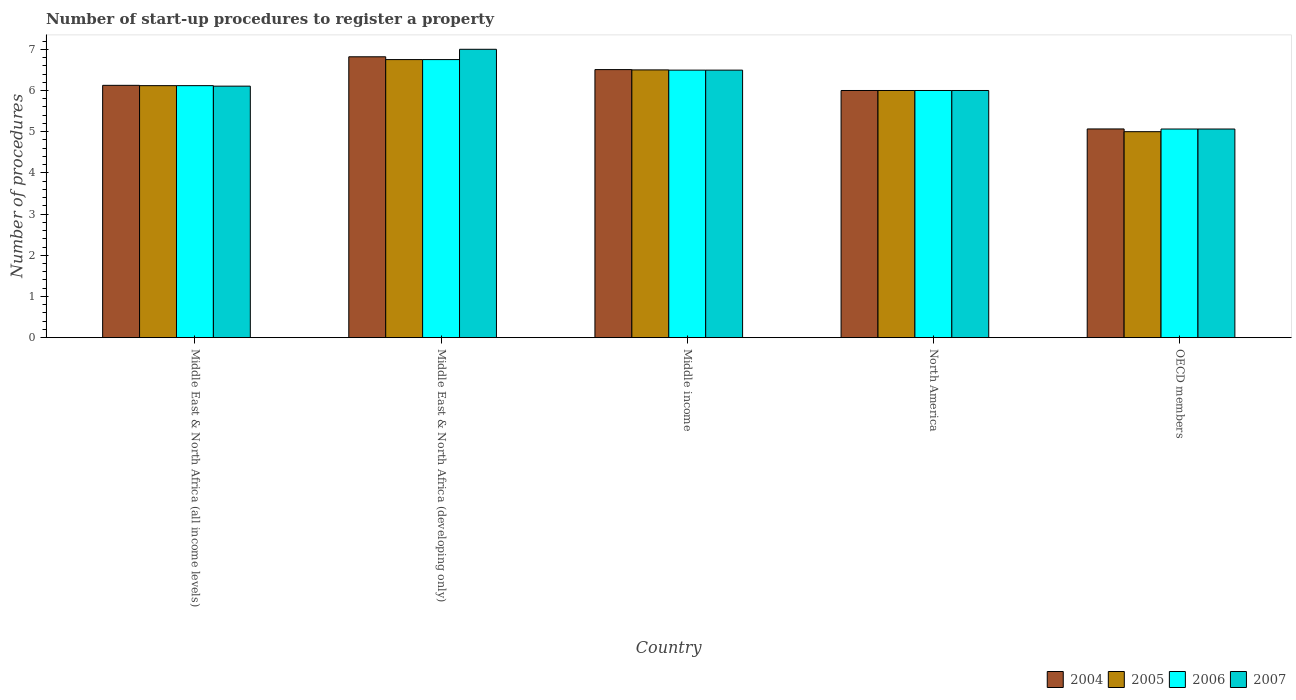Are the number of bars per tick equal to the number of legend labels?
Your answer should be very brief. Yes. How many bars are there on the 2nd tick from the left?
Offer a very short reply. 4. How many bars are there on the 5th tick from the right?
Offer a terse response. 4. What is the number of procedures required to register a property in 2004 in Middle East & North Africa (all income levels)?
Ensure brevity in your answer.  6.12. Across all countries, what is the maximum number of procedures required to register a property in 2005?
Offer a very short reply. 6.75. Across all countries, what is the minimum number of procedures required to register a property in 2005?
Your answer should be compact. 5. In which country was the number of procedures required to register a property in 2007 maximum?
Your response must be concise. Middle East & North Africa (developing only). In which country was the number of procedures required to register a property in 2006 minimum?
Provide a short and direct response. OECD members. What is the total number of procedures required to register a property in 2005 in the graph?
Make the answer very short. 30.37. What is the difference between the number of procedures required to register a property in 2005 in Middle East & North Africa (developing only) and that in Middle income?
Make the answer very short. 0.25. What is the difference between the number of procedures required to register a property in 2005 in Middle East & North Africa (developing only) and the number of procedures required to register a property in 2007 in Middle East & North Africa (all income levels)?
Provide a short and direct response. 0.64. What is the average number of procedures required to register a property in 2006 per country?
Give a very brief answer. 6.09. In how many countries, is the number of procedures required to register a property in 2006 greater than 0.4?
Your answer should be compact. 5. What is the ratio of the number of procedures required to register a property in 2006 in Middle income to that in North America?
Make the answer very short. 1.08. Is the number of procedures required to register a property in 2005 in Middle income less than that in North America?
Give a very brief answer. No. Is the difference between the number of procedures required to register a property in 2005 in Middle East & North Africa (all income levels) and OECD members greater than the difference between the number of procedures required to register a property in 2006 in Middle East & North Africa (all income levels) and OECD members?
Offer a very short reply. Yes. What is the difference between the highest and the second highest number of procedures required to register a property in 2004?
Keep it short and to the point. -0.69. What is the difference between the highest and the lowest number of procedures required to register a property in 2006?
Your response must be concise. 1.69. Is the sum of the number of procedures required to register a property in 2007 in Middle East & North Africa (developing only) and OECD members greater than the maximum number of procedures required to register a property in 2004 across all countries?
Offer a terse response. Yes. What does the 4th bar from the right in North America represents?
Make the answer very short. 2004. Is it the case that in every country, the sum of the number of procedures required to register a property in 2006 and number of procedures required to register a property in 2004 is greater than the number of procedures required to register a property in 2007?
Make the answer very short. Yes. Are all the bars in the graph horizontal?
Your response must be concise. No. What is the difference between two consecutive major ticks on the Y-axis?
Provide a succinct answer. 1. Does the graph contain any zero values?
Ensure brevity in your answer.  No. Where does the legend appear in the graph?
Ensure brevity in your answer.  Bottom right. How many legend labels are there?
Provide a short and direct response. 4. What is the title of the graph?
Make the answer very short. Number of start-up procedures to register a property. Does "1985" appear as one of the legend labels in the graph?
Provide a succinct answer. No. What is the label or title of the Y-axis?
Provide a short and direct response. Number of procedures. What is the Number of procedures in 2004 in Middle East & North Africa (all income levels)?
Provide a succinct answer. 6.12. What is the Number of procedures of 2005 in Middle East & North Africa (all income levels)?
Your answer should be very brief. 6.12. What is the Number of procedures of 2006 in Middle East & North Africa (all income levels)?
Give a very brief answer. 6.12. What is the Number of procedures of 2007 in Middle East & North Africa (all income levels)?
Offer a very short reply. 6.11. What is the Number of procedures in 2004 in Middle East & North Africa (developing only)?
Provide a succinct answer. 6.82. What is the Number of procedures of 2005 in Middle East & North Africa (developing only)?
Make the answer very short. 6.75. What is the Number of procedures of 2006 in Middle East & North Africa (developing only)?
Provide a succinct answer. 6.75. What is the Number of procedures in 2004 in Middle income?
Offer a very short reply. 6.51. What is the Number of procedures of 2005 in Middle income?
Provide a succinct answer. 6.5. What is the Number of procedures of 2006 in Middle income?
Make the answer very short. 6.49. What is the Number of procedures of 2007 in Middle income?
Your answer should be very brief. 6.49. What is the Number of procedures of 2005 in North America?
Make the answer very short. 6. What is the Number of procedures in 2004 in OECD members?
Your response must be concise. 5.07. What is the Number of procedures of 2006 in OECD members?
Provide a short and direct response. 5.06. What is the Number of procedures in 2007 in OECD members?
Give a very brief answer. 5.06. Across all countries, what is the maximum Number of procedures of 2004?
Your answer should be very brief. 6.82. Across all countries, what is the maximum Number of procedures in 2005?
Give a very brief answer. 6.75. Across all countries, what is the maximum Number of procedures in 2006?
Provide a short and direct response. 6.75. Across all countries, what is the minimum Number of procedures of 2004?
Your answer should be compact. 5.07. Across all countries, what is the minimum Number of procedures of 2006?
Ensure brevity in your answer.  5.06. Across all countries, what is the minimum Number of procedures in 2007?
Your answer should be compact. 5.06. What is the total Number of procedures of 2004 in the graph?
Offer a very short reply. 30.52. What is the total Number of procedures in 2005 in the graph?
Give a very brief answer. 30.37. What is the total Number of procedures in 2006 in the graph?
Provide a succinct answer. 30.43. What is the total Number of procedures in 2007 in the graph?
Keep it short and to the point. 30.66. What is the difference between the Number of procedures in 2004 in Middle East & North Africa (all income levels) and that in Middle East & North Africa (developing only)?
Keep it short and to the point. -0.69. What is the difference between the Number of procedures in 2005 in Middle East & North Africa (all income levels) and that in Middle East & North Africa (developing only)?
Ensure brevity in your answer.  -0.63. What is the difference between the Number of procedures in 2006 in Middle East & North Africa (all income levels) and that in Middle East & North Africa (developing only)?
Your answer should be compact. -0.63. What is the difference between the Number of procedures of 2007 in Middle East & North Africa (all income levels) and that in Middle East & North Africa (developing only)?
Offer a terse response. -0.89. What is the difference between the Number of procedures of 2004 in Middle East & North Africa (all income levels) and that in Middle income?
Your response must be concise. -0.38. What is the difference between the Number of procedures of 2005 in Middle East & North Africa (all income levels) and that in Middle income?
Provide a succinct answer. -0.38. What is the difference between the Number of procedures in 2006 in Middle East & North Africa (all income levels) and that in Middle income?
Give a very brief answer. -0.38. What is the difference between the Number of procedures in 2007 in Middle East & North Africa (all income levels) and that in Middle income?
Your answer should be very brief. -0.39. What is the difference between the Number of procedures of 2004 in Middle East & North Africa (all income levels) and that in North America?
Offer a terse response. 0.12. What is the difference between the Number of procedures in 2005 in Middle East & North Africa (all income levels) and that in North America?
Ensure brevity in your answer.  0.12. What is the difference between the Number of procedures of 2006 in Middle East & North Africa (all income levels) and that in North America?
Provide a succinct answer. 0.12. What is the difference between the Number of procedures in 2007 in Middle East & North Africa (all income levels) and that in North America?
Provide a succinct answer. 0.11. What is the difference between the Number of procedures in 2004 in Middle East & North Africa (all income levels) and that in OECD members?
Provide a short and direct response. 1.06. What is the difference between the Number of procedures in 2005 in Middle East & North Africa (all income levels) and that in OECD members?
Offer a very short reply. 1.12. What is the difference between the Number of procedures in 2006 in Middle East & North Africa (all income levels) and that in OECD members?
Make the answer very short. 1.05. What is the difference between the Number of procedures of 2007 in Middle East & North Africa (all income levels) and that in OECD members?
Your answer should be compact. 1.04. What is the difference between the Number of procedures in 2004 in Middle East & North Africa (developing only) and that in Middle income?
Provide a short and direct response. 0.31. What is the difference between the Number of procedures in 2005 in Middle East & North Africa (developing only) and that in Middle income?
Your response must be concise. 0.25. What is the difference between the Number of procedures of 2006 in Middle East & North Africa (developing only) and that in Middle income?
Keep it short and to the point. 0.26. What is the difference between the Number of procedures of 2007 in Middle East & North Africa (developing only) and that in Middle income?
Offer a terse response. 0.51. What is the difference between the Number of procedures of 2004 in Middle East & North Africa (developing only) and that in North America?
Provide a succinct answer. 0.82. What is the difference between the Number of procedures in 2006 in Middle East & North Africa (developing only) and that in North America?
Your answer should be very brief. 0.75. What is the difference between the Number of procedures of 2007 in Middle East & North Africa (developing only) and that in North America?
Make the answer very short. 1. What is the difference between the Number of procedures in 2004 in Middle East & North Africa (developing only) and that in OECD members?
Your response must be concise. 1.75. What is the difference between the Number of procedures in 2005 in Middle East & North Africa (developing only) and that in OECD members?
Your answer should be very brief. 1.75. What is the difference between the Number of procedures of 2006 in Middle East & North Africa (developing only) and that in OECD members?
Provide a succinct answer. 1.69. What is the difference between the Number of procedures in 2007 in Middle East & North Africa (developing only) and that in OECD members?
Keep it short and to the point. 1.94. What is the difference between the Number of procedures in 2004 in Middle income and that in North America?
Give a very brief answer. 0.51. What is the difference between the Number of procedures in 2006 in Middle income and that in North America?
Offer a terse response. 0.49. What is the difference between the Number of procedures of 2007 in Middle income and that in North America?
Make the answer very short. 0.49. What is the difference between the Number of procedures in 2004 in Middle income and that in OECD members?
Keep it short and to the point. 1.44. What is the difference between the Number of procedures in 2005 in Middle income and that in OECD members?
Offer a terse response. 1.5. What is the difference between the Number of procedures of 2006 in Middle income and that in OECD members?
Ensure brevity in your answer.  1.43. What is the difference between the Number of procedures of 2007 in Middle income and that in OECD members?
Your answer should be compact. 1.43. What is the difference between the Number of procedures in 2004 in North America and that in OECD members?
Make the answer very short. 0.93. What is the difference between the Number of procedures in 2006 in North America and that in OECD members?
Your answer should be compact. 0.94. What is the difference between the Number of procedures in 2007 in North America and that in OECD members?
Provide a short and direct response. 0.94. What is the difference between the Number of procedures in 2004 in Middle East & North Africa (all income levels) and the Number of procedures in 2005 in Middle East & North Africa (developing only)?
Keep it short and to the point. -0.62. What is the difference between the Number of procedures in 2004 in Middle East & North Africa (all income levels) and the Number of procedures in 2006 in Middle East & North Africa (developing only)?
Provide a short and direct response. -0.62. What is the difference between the Number of procedures in 2004 in Middle East & North Africa (all income levels) and the Number of procedures in 2007 in Middle East & North Africa (developing only)?
Offer a terse response. -0.88. What is the difference between the Number of procedures in 2005 in Middle East & North Africa (all income levels) and the Number of procedures in 2006 in Middle East & North Africa (developing only)?
Offer a very short reply. -0.63. What is the difference between the Number of procedures of 2005 in Middle East & North Africa (all income levels) and the Number of procedures of 2007 in Middle East & North Africa (developing only)?
Provide a succinct answer. -0.88. What is the difference between the Number of procedures in 2006 in Middle East & North Africa (all income levels) and the Number of procedures in 2007 in Middle East & North Africa (developing only)?
Make the answer very short. -0.88. What is the difference between the Number of procedures in 2004 in Middle East & North Africa (all income levels) and the Number of procedures in 2005 in Middle income?
Your response must be concise. -0.38. What is the difference between the Number of procedures of 2004 in Middle East & North Africa (all income levels) and the Number of procedures of 2006 in Middle income?
Provide a short and direct response. -0.37. What is the difference between the Number of procedures of 2004 in Middle East & North Africa (all income levels) and the Number of procedures of 2007 in Middle income?
Your answer should be compact. -0.37. What is the difference between the Number of procedures of 2005 in Middle East & North Africa (all income levels) and the Number of procedures of 2006 in Middle income?
Make the answer very short. -0.38. What is the difference between the Number of procedures of 2005 in Middle East & North Africa (all income levels) and the Number of procedures of 2007 in Middle income?
Your answer should be very brief. -0.38. What is the difference between the Number of procedures in 2006 in Middle East & North Africa (all income levels) and the Number of procedures in 2007 in Middle income?
Offer a terse response. -0.38. What is the difference between the Number of procedures in 2004 in Middle East & North Africa (all income levels) and the Number of procedures in 2005 in North America?
Your response must be concise. 0.12. What is the difference between the Number of procedures of 2005 in Middle East & North Africa (all income levels) and the Number of procedures of 2006 in North America?
Your response must be concise. 0.12. What is the difference between the Number of procedures in 2005 in Middle East & North Africa (all income levels) and the Number of procedures in 2007 in North America?
Your response must be concise. 0.12. What is the difference between the Number of procedures of 2006 in Middle East & North Africa (all income levels) and the Number of procedures of 2007 in North America?
Your response must be concise. 0.12. What is the difference between the Number of procedures of 2004 in Middle East & North Africa (all income levels) and the Number of procedures of 2006 in OECD members?
Keep it short and to the point. 1.06. What is the difference between the Number of procedures of 2004 in Middle East & North Africa (all income levels) and the Number of procedures of 2007 in OECD members?
Keep it short and to the point. 1.06. What is the difference between the Number of procedures of 2005 in Middle East & North Africa (all income levels) and the Number of procedures of 2006 in OECD members?
Provide a succinct answer. 1.05. What is the difference between the Number of procedures in 2005 in Middle East & North Africa (all income levels) and the Number of procedures in 2007 in OECD members?
Offer a terse response. 1.05. What is the difference between the Number of procedures in 2006 in Middle East & North Africa (all income levels) and the Number of procedures in 2007 in OECD members?
Offer a very short reply. 1.05. What is the difference between the Number of procedures in 2004 in Middle East & North Africa (developing only) and the Number of procedures in 2005 in Middle income?
Offer a terse response. 0.32. What is the difference between the Number of procedures of 2004 in Middle East & North Africa (developing only) and the Number of procedures of 2006 in Middle income?
Give a very brief answer. 0.32. What is the difference between the Number of procedures in 2004 in Middle East & North Africa (developing only) and the Number of procedures in 2007 in Middle income?
Make the answer very short. 0.32. What is the difference between the Number of procedures of 2005 in Middle East & North Africa (developing only) and the Number of procedures of 2006 in Middle income?
Keep it short and to the point. 0.26. What is the difference between the Number of procedures of 2005 in Middle East & North Africa (developing only) and the Number of procedures of 2007 in Middle income?
Your answer should be compact. 0.26. What is the difference between the Number of procedures in 2006 in Middle East & North Africa (developing only) and the Number of procedures in 2007 in Middle income?
Your answer should be very brief. 0.26. What is the difference between the Number of procedures in 2004 in Middle East & North Africa (developing only) and the Number of procedures in 2005 in North America?
Provide a short and direct response. 0.82. What is the difference between the Number of procedures of 2004 in Middle East & North Africa (developing only) and the Number of procedures of 2006 in North America?
Give a very brief answer. 0.82. What is the difference between the Number of procedures of 2004 in Middle East & North Africa (developing only) and the Number of procedures of 2007 in North America?
Make the answer very short. 0.82. What is the difference between the Number of procedures in 2005 in Middle East & North Africa (developing only) and the Number of procedures in 2007 in North America?
Keep it short and to the point. 0.75. What is the difference between the Number of procedures in 2006 in Middle East & North Africa (developing only) and the Number of procedures in 2007 in North America?
Provide a short and direct response. 0.75. What is the difference between the Number of procedures in 2004 in Middle East & North Africa (developing only) and the Number of procedures in 2005 in OECD members?
Provide a short and direct response. 1.82. What is the difference between the Number of procedures in 2004 in Middle East & North Africa (developing only) and the Number of procedures in 2006 in OECD members?
Provide a succinct answer. 1.75. What is the difference between the Number of procedures of 2004 in Middle East & North Africa (developing only) and the Number of procedures of 2007 in OECD members?
Keep it short and to the point. 1.75. What is the difference between the Number of procedures of 2005 in Middle East & North Africa (developing only) and the Number of procedures of 2006 in OECD members?
Give a very brief answer. 1.69. What is the difference between the Number of procedures of 2005 in Middle East & North Africa (developing only) and the Number of procedures of 2007 in OECD members?
Keep it short and to the point. 1.69. What is the difference between the Number of procedures of 2006 in Middle East & North Africa (developing only) and the Number of procedures of 2007 in OECD members?
Give a very brief answer. 1.69. What is the difference between the Number of procedures in 2004 in Middle income and the Number of procedures in 2005 in North America?
Make the answer very short. 0.51. What is the difference between the Number of procedures of 2004 in Middle income and the Number of procedures of 2006 in North America?
Offer a very short reply. 0.51. What is the difference between the Number of procedures in 2004 in Middle income and the Number of procedures in 2007 in North America?
Ensure brevity in your answer.  0.51. What is the difference between the Number of procedures of 2005 in Middle income and the Number of procedures of 2007 in North America?
Keep it short and to the point. 0.5. What is the difference between the Number of procedures in 2006 in Middle income and the Number of procedures in 2007 in North America?
Offer a terse response. 0.49. What is the difference between the Number of procedures of 2004 in Middle income and the Number of procedures of 2005 in OECD members?
Offer a very short reply. 1.51. What is the difference between the Number of procedures of 2004 in Middle income and the Number of procedures of 2006 in OECD members?
Ensure brevity in your answer.  1.44. What is the difference between the Number of procedures of 2004 in Middle income and the Number of procedures of 2007 in OECD members?
Offer a terse response. 1.44. What is the difference between the Number of procedures in 2005 in Middle income and the Number of procedures in 2006 in OECD members?
Offer a very short reply. 1.44. What is the difference between the Number of procedures of 2005 in Middle income and the Number of procedures of 2007 in OECD members?
Your answer should be compact. 1.44. What is the difference between the Number of procedures of 2006 in Middle income and the Number of procedures of 2007 in OECD members?
Your response must be concise. 1.43. What is the difference between the Number of procedures in 2004 in North America and the Number of procedures in 2005 in OECD members?
Your response must be concise. 1. What is the difference between the Number of procedures in 2004 in North America and the Number of procedures in 2006 in OECD members?
Offer a terse response. 0.94. What is the difference between the Number of procedures in 2004 in North America and the Number of procedures in 2007 in OECD members?
Give a very brief answer. 0.94. What is the difference between the Number of procedures in 2005 in North America and the Number of procedures in 2006 in OECD members?
Offer a terse response. 0.94. What is the difference between the Number of procedures of 2005 in North America and the Number of procedures of 2007 in OECD members?
Provide a succinct answer. 0.94. What is the difference between the Number of procedures of 2006 in North America and the Number of procedures of 2007 in OECD members?
Keep it short and to the point. 0.94. What is the average Number of procedures in 2004 per country?
Offer a very short reply. 6.1. What is the average Number of procedures in 2005 per country?
Your response must be concise. 6.07. What is the average Number of procedures in 2006 per country?
Provide a short and direct response. 6.09. What is the average Number of procedures in 2007 per country?
Make the answer very short. 6.13. What is the difference between the Number of procedures in 2004 and Number of procedures in 2005 in Middle East & North Africa (all income levels)?
Provide a short and direct response. 0.01. What is the difference between the Number of procedures of 2004 and Number of procedures of 2006 in Middle East & North Africa (all income levels)?
Offer a terse response. 0.01. What is the difference between the Number of procedures of 2004 and Number of procedures of 2007 in Middle East & North Africa (all income levels)?
Your answer should be very brief. 0.02. What is the difference between the Number of procedures in 2005 and Number of procedures in 2006 in Middle East & North Africa (all income levels)?
Provide a succinct answer. 0. What is the difference between the Number of procedures of 2005 and Number of procedures of 2007 in Middle East & North Africa (all income levels)?
Make the answer very short. 0.01. What is the difference between the Number of procedures in 2006 and Number of procedures in 2007 in Middle East & North Africa (all income levels)?
Keep it short and to the point. 0.01. What is the difference between the Number of procedures in 2004 and Number of procedures in 2005 in Middle East & North Africa (developing only)?
Your response must be concise. 0.07. What is the difference between the Number of procedures of 2004 and Number of procedures of 2006 in Middle East & North Africa (developing only)?
Offer a terse response. 0.07. What is the difference between the Number of procedures in 2004 and Number of procedures in 2007 in Middle East & North Africa (developing only)?
Give a very brief answer. -0.18. What is the difference between the Number of procedures of 2004 and Number of procedures of 2005 in Middle income?
Your answer should be compact. 0.01. What is the difference between the Number of procedures in 2004 and Number of procedures in 2006 in Middle income?
Your response must be concise. 0.01. What is the difference between the Number of procedures of 2004 and Number of procedures of 2007 in Middle income?
Make the answer very short. 0.01. What is the difference between the Number of procedures of 2005 and Number of procedures of 2006 in Middle income?
Your answer should be very brief. 0.01. What is the difference between the Number of procedures in 2005 and Number of procedures in 2007 in Middle income?
Your response must be concise. 0.01. What is the difference between the Number of procedures in 2006 and Number of procedures in 2007 in Middle income?
Keep it short and to the point. 0. What is the difference between the Number of procedures in 2004 and Number of procedures in 2005 in North America?
Offer a terse response. 0. What is the difference between the Number of procedures in 2004 and Number of procedures in 2006 in North America?
Make the answer very short. 0. What is the difference between the Number of procedures in 2005 and Number of procedures in 2007 in North America?
Provide a succinct answer. 0. What is the difference between the Number of procedures of 2004 and Number of procedures of 2005 in OECD members?
Keep it short and to the point. 0.07. What is the difference between the Number of procedures in 2004 and Number of procedures in 2006 in OECD members?
Your answer should be compact. 0. What is the difference between the Number of procedures of 2004 and Number of procedures of 2007 in OECD members?
Your response must be concise. 0. What is the difference between the Number of procedures in 2005 and Number of procedures in 2006 in OECD members?
Provide a short and direct response. -0.06. What is the difference between the Number of procedures in 2005 and Number of procedures in 2007 in OECD members?
Give a very brief answer. -0.06. What is the ratio of the Number of procedures of 2004 in Middle East & North Africa (all income levels) to that in Middle East & North Africa (developing only)?
Offer a very short reply. 0.9. What is the ratio of the Number of procedures in 2005 in Middle East & North Africa (all income levels) to that in Middle East & North Africa (developing only)?
Your response must be concise. 0.91. What is the ratio of the Number of procedures of 2006 in Middle East & North Africa (all income levels) to that in Middle East & North Africa (developing only)?
Your answer should be very brief. 0.91. What is the ratio of the Number of procedures of 2007 in Middle East & North Africa (all income levels) to that in Middle East & North Africa (developing only)?
Provide a short and direct response. 0.87. What is the ratio of the Number of procedures in 2004 in Middle East & North Africa (all income levels) to that in Middle income?
Ensure brevity in your answer.  0.94. What is the ratio of the Number of procedures in 2006 in Middle East & North Africa (all income levels) to that in Middle income?
Keep it short and to the point. 0.94. What is the ratio of the Number of procedures in 2007 in Middle East & North Africa (all income levels) to that in Middle income?
Your response must be concise. 0.94. What is the ratio of the Number of procedures of 2004 in Middle East & North Africa (all income levels) to that in North America?
Give a very brief answer. 1.02. What is the ratio of the Number of procedures in 2005 in Middle East & North Africa (all income levels) to that in North America?
Offer a terse response. 1.02. What is the ratio of the Number of procedures in 2006 in Middle East & North Africa (all income levels) to that in North America?
Ensure brevity in your answer.  1.02. What is the ratio of the Number of procedures in 2007 in Middle East & North Africa (all income levels) to that in North America?
Your answer should be very brief. 1.02. What is the ratio of the Number of procedures in 2004 in Middle East & North Africa (all income levels) to that in OECD members?
Your answer should be compact. 1.21. What is the ratio of the Number of procedures of 2005 in Middle East & North Africa (all income levels) to that in OECD members?
Give a very brief answer. 1.22. What is the ratio of the Number of procedures in 2006 in Middle East & North Africa (all income levels) to that in OECD members?
Your answer should be very brief. 1.21. What is the ratio of the Number of procedures in 2007 in Middle East & North Africa (all income levels) to that in OECD members?
Ensure brevity in your answer.  1.21. What is the ratio of the Number of procedures of 2004 in Middle East & North Africa (developing only) to that in Middle income?
Ensure brevity in your answer.  1.05. What is the ratio of the Number of procedures of 2006 in Middle East & North Africa (developing only) to that in Middle income?
Provide a short and direct response. 1.04. What is the ratio of the Number of procedures in 2007 in Middle East & North Africa (developing only) to that in Middle income?
Your answer should be compact. 1.08. What is the ratio of the Number of procedures in 2004 in Middle East & North Africa (developing only) to that in North America?
Your answer should be very brief. 1.14. What is the ratio of the Number of procedures of 2006 in Middle East & North Africa (developing only) to that in North America?
Ensure brevity in your answer.  1.12. What is the ratio of the Number of procedures of 2007 in Middle East & North Africa (developing only) to that in North America?
Offer a terse response. 1.17. What is the ratio of the Number of procedures of 2004 in Middle East & North Africa (developing only) to that in OECD members?
Offer a very short reply. 1.35. What is the ratio of the Number of procedures of 2005 in Middle East & North Africa (developing only) to that in OECD members?
Make the answer very short. 1.35. What is the ratio of the Number of procedures in 2006 in Middle East & North Africa (developing only) to that in OECD members?
Make the answer very short. 1.33. What is the ratio of the Number of procedures in 2007 in Middle East & North Africa (developing only) to that in OECD members?
Your response must be concise. 1.38. What is the ratio of the Number of procedures of 2004 in Middle income to that in North America?
Give a very brief answer. 1.08. What is the ratio of the Number of procedures in 2005 in Middle income to that in North America?
Your answer should be compact. 1.08. What is the ratio of the Number of procedures of 2006 in Middle income to that in North America?
Offer a terse response. 1.08. What is the ratio of the Number of procedures in 2007 in Middle income to that in North America?
Your response must be concise. 1.08. What is the ratio of the Number of procedures of 2004 in Middle income to that in OECD members?
Keep it short and to the point. 1.28. What is the ratio of the Number of procedures in 2006 in Middle income to that in OECD members?
Your answer should be compact. 1.28. What is the ratio of the Number of procedures of 2007 in Middle income to that in OECD members?
Provide a succinct answer. 1.28. What is the ratio of the Number of procedures of 2004 in North America to that in OECD members?
Give a very brief answer. 1.18. What is the ratio of the Number of procedures of 2005 in North America to that in OECD members?
Offer a very short reply. 1.2. What is the ratio of the Number of procedures in 2006 in North America to that in OECD members?
Your answer should be very brief. 1.18. What is the ratio of the Number of procedures of 2007 in North America to that in OECD members?
Provide a short and direct response. 1.18. What is the difference between the highest and the second highest Number of procedures in 2004?
Your answer should be very brief. 0.31. What is the difference between the highest and the second highest Number of procedures of 2006?
Provide a short and direct response. 0.26. What is the difference between the highest and the second highest Number of procedures of 2007?
Your response must be concise. 0.51. What is the difference between the highest and the lowest Number of procedures of 2004?
Your response must be concise. 1.75. What is the difference between the highest and the lowest Number of procedures of 2006?
Your response must be concise. 1.69. What is the difference between the highest and the lowest Number of procedures in 2007?
Provide a short and direct response. 1.94. 